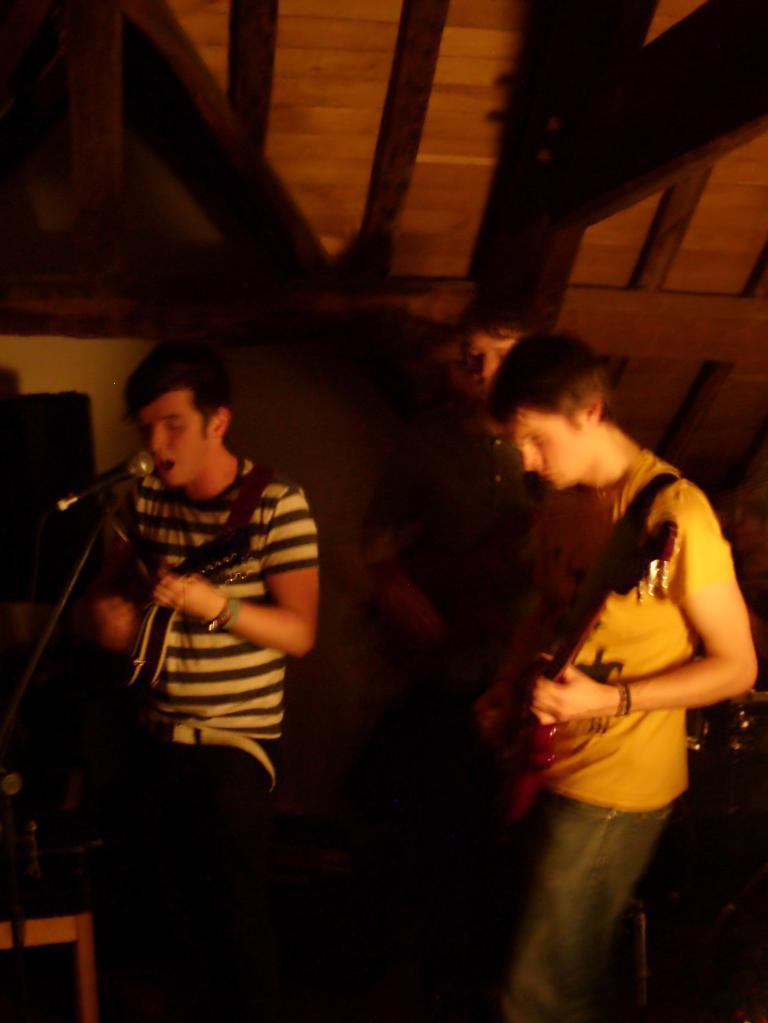What are the two men in the image doing? The two men in the image are playing guitar. What is the third person in the image doing? The third person in the image is singing. How is the singer amplifying his voice in the image? The singer is using a microphone. What type of linen is draped over the gate in the image? There is no gate or linen present in the image; it features two men playing guitar and a singer using a microphone. 